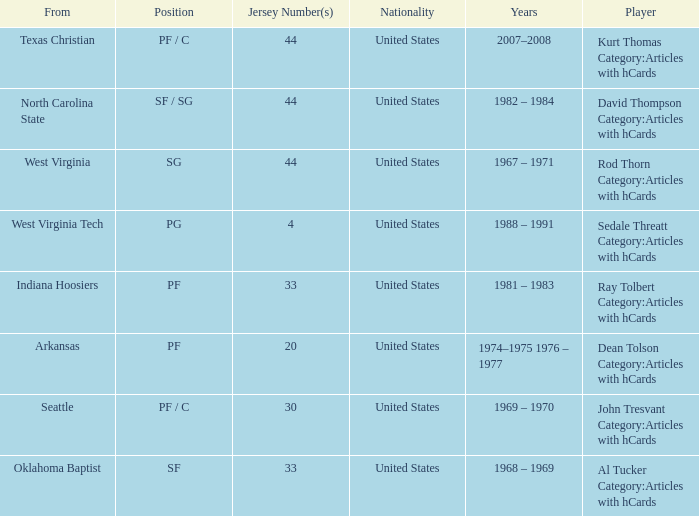What was the highest jersey number for the player from oklahoma baptist? 33.0. 